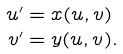<formula> <loc_0><loc_0><loc_500><loc_500>u ^ { \prime } & = x ( u , v ) \\ v ^ { \prime } & = y ( u , v ) .</formula> 